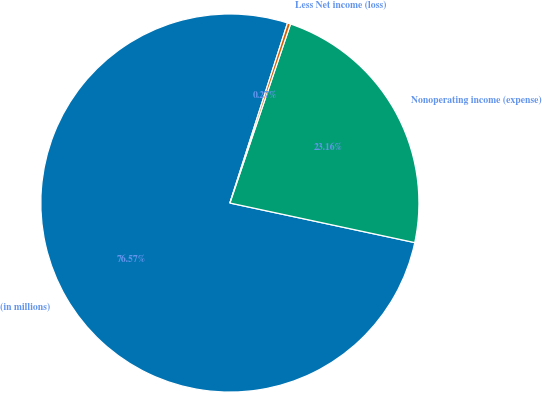Convert chart. <chart><loc_0><loc_0><loc_500><loc_500><pie_chart><fcel>(in millions)<fcel>Nonoperating income (expense)<fcel>Less Net income (loss)<nl><fcel>76.58%<fcel>23.16%<fcel>0.27%<nl></chart> 